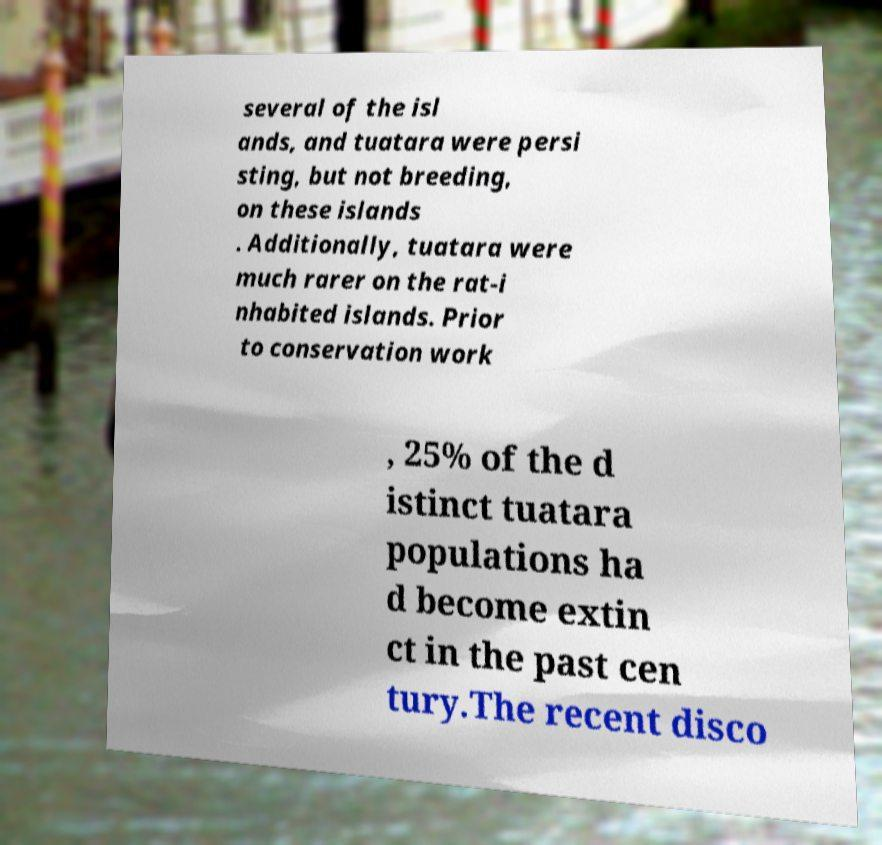What messages or text are displayed in this image? I need them in a readable, typed format. several of the isl ands, and tuatara were persi sting, but not breeding, on these islands . Additionally, tuatara were much rarer on the rat-i nhabited islands. Prior to conservation work , 25% of the d istinct tuatara populations ha d become extin ct in the past cen tury.The recent disco 